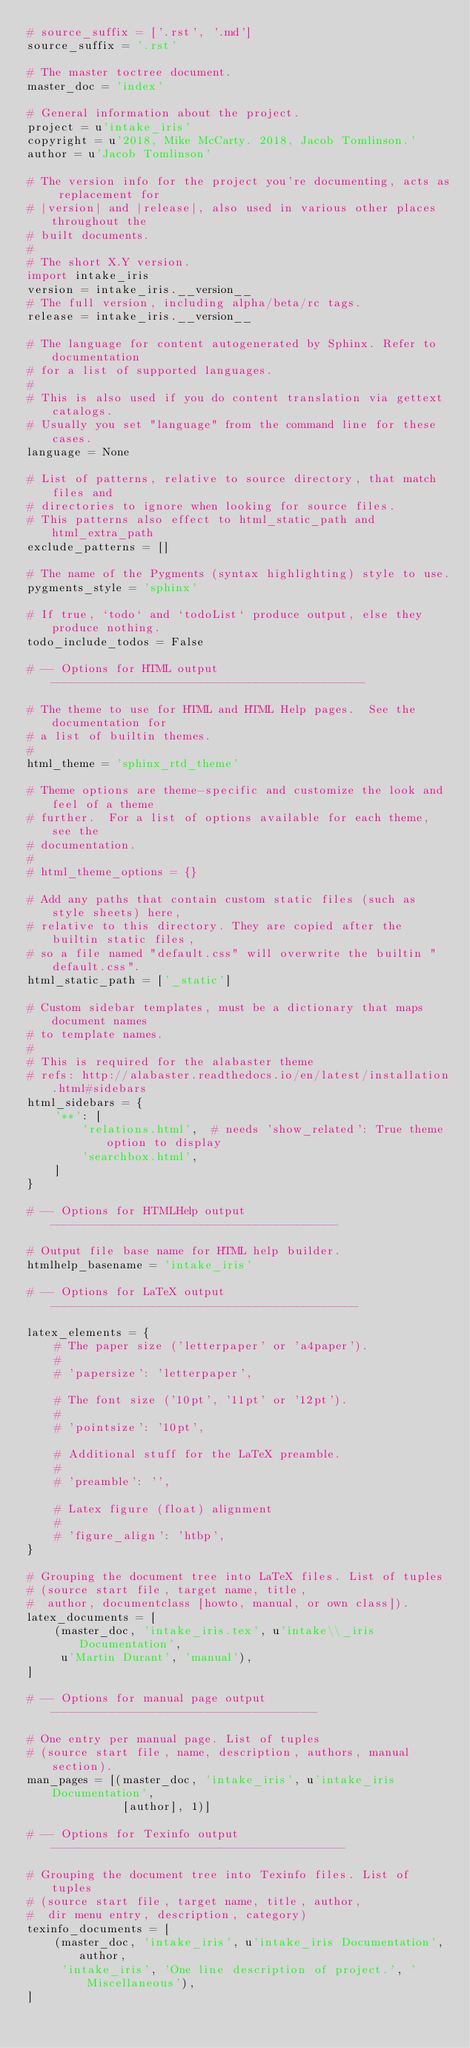<code> <loc_0><loc_0><loc_500><loc_500><_Python_># source_suffix = ['.rst', '.md']
source_suffix = '.rst'

# The master toctree document.
master_doc = 'index'

# General information about the project.
project = u'intake_iris'
copyright = u'2018, Mike McCarty. 2018, Jacob Tomlinson.'
author = u'Jacob Tomlinson'

# The version info for the project you're documenting, acts as replacement for
# |version| and |release|, also used in various other places throughout the
# built documents.
#
# The short X.Y version.
import intake_iris
version = intake_iris.__version__
# The full version, including alpha/beta/rc tags.
release = intake_iris.__version__

# The language for content autogenerated by Sphinx. Refer to documentation
# for a list of supported languages.
#
# This is also used if you do content translation via gettext catalogs.
# Usually you set "language" from the command line for these cases.
language = None

# List of patterns, relative to source directory, that match files and
# directories to ignore when looking for source files.
# This patterns also effect to html_static_path and html_extra_path
exclude_patterns = []

# The name of the Pygments (syntax highlighting) style to use.
pygments_style = 'sphinx'

# If true, `todo` and `todoList` produce output, else they produce nothing.
todo_include_todos = False

# -- Options for HTML output ----------------------------------------------

# The theme to use for HTML and HTML Help pages.  See the documentation for
# a list of builtin themes.
#
html_theme = 'sphinx_rtd_theme'

# Theme options are theme-specific and customize the look and feel of a theme
# further.  For a list of options available for each theme, see the
# documentation.
#
# html_theme_options = {}

# Add any paths that contain custom static files (such as style sheets) here,
# relative to this directory. They are copied after the builtin static files,
# so a file named "default.css" will overwrite the builtin "default.css".
html_static_path = ['_static']

# Custom sidebar templates, must be a dictionary that maps document names
# to template names.
#
# This is required for the alabaster theme
# refs: http://alabaster.readthedocs.io/en/latest/installation.html#sidebars
html_sidebars = {
    '**': [
        'relations.html',  # needs 'show_related': True theme option to display
        'searchbox.html',
    ]
}

# -- Options for HTMLHelp output ------------------------------------------

# Output file base name for HTML help builder.
htmlhelp_basename = 'intake_iris'

# -- Options for LaTeX output ---------------------------------------------

latex_elements = {
    # The paper size ('letterpaper' or 'a4paper').
    #
    # 'papersize': 'letterpaper',

    # The font size ('10pt', '11pt' or '12pt').
    #
    # 'pointsize': '10pt',

    # Additional stuff for the LaTeX preamble.
    #
    # 'preamble': '',

    # Latex figure (float) alignment
    #
    # 'figure_align': 'htbp',
}

# Grouping the document tree into LaTeX files. List of tuples
# (source start file, target name, title,
#  author, documentclass [howto, manual, or own class]).
latex_documents = [
    (master_doc, 'intake_iris.tex', u'intake\\_iris Documentation',
     u'Martin Durant', 'manual'),
]

# -- Options for manual page output ---------------------------------------

# One entry per manual page. List of tuples
# (source start file, name, description, authors, manual section).
man_pages = [(master_doc, 'intake_iris', u'intake_iris Documentation',
              [author], 1)]

# -- Options for Texinfo output -------------------------------------------

# Grouping the document tree into Texinfo files. List of tuples
# (source start file, target name, title, author,
#  dir menu entry, description, category)
texinfo_documents = [
    (master_doc, 'intake_iris', u'intake_iris Documentation', author,
     'intake_iris', 'One line description of project.', 'Miscellaneous'),
]
</code> 